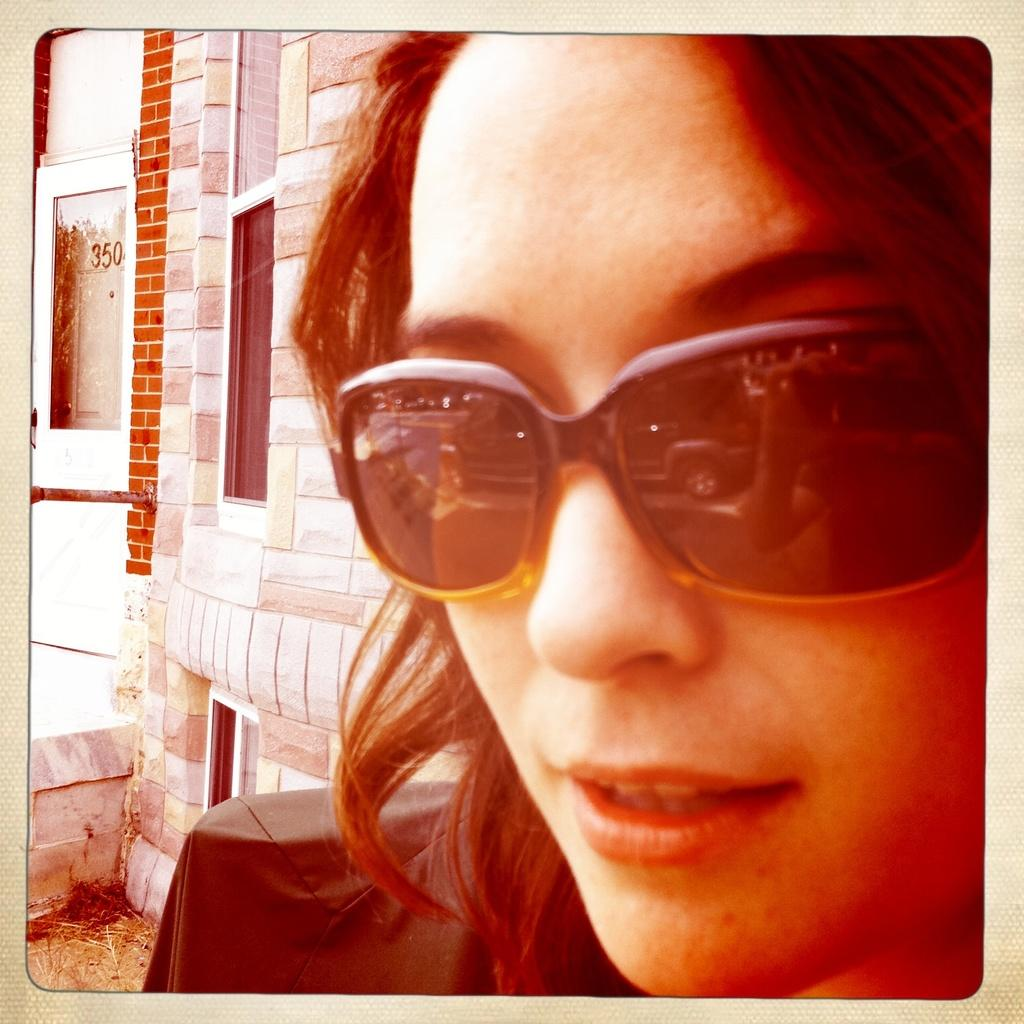What is the main subject of the image? There is a photograph in the image. What can be seen in the photograph? The photograph contains a person. What is the person wearing in the photograph? The person is wearing goggles. What is visible in the background of the photograph? There is a building in the background of the photograph. What architectural feature can be seen on the building? There are windows visible on the building. What degree does the person in the photograph have? There is no information about the person's degree in the image. Is there any smoke visible in the image? There is no smoke present in the image. 